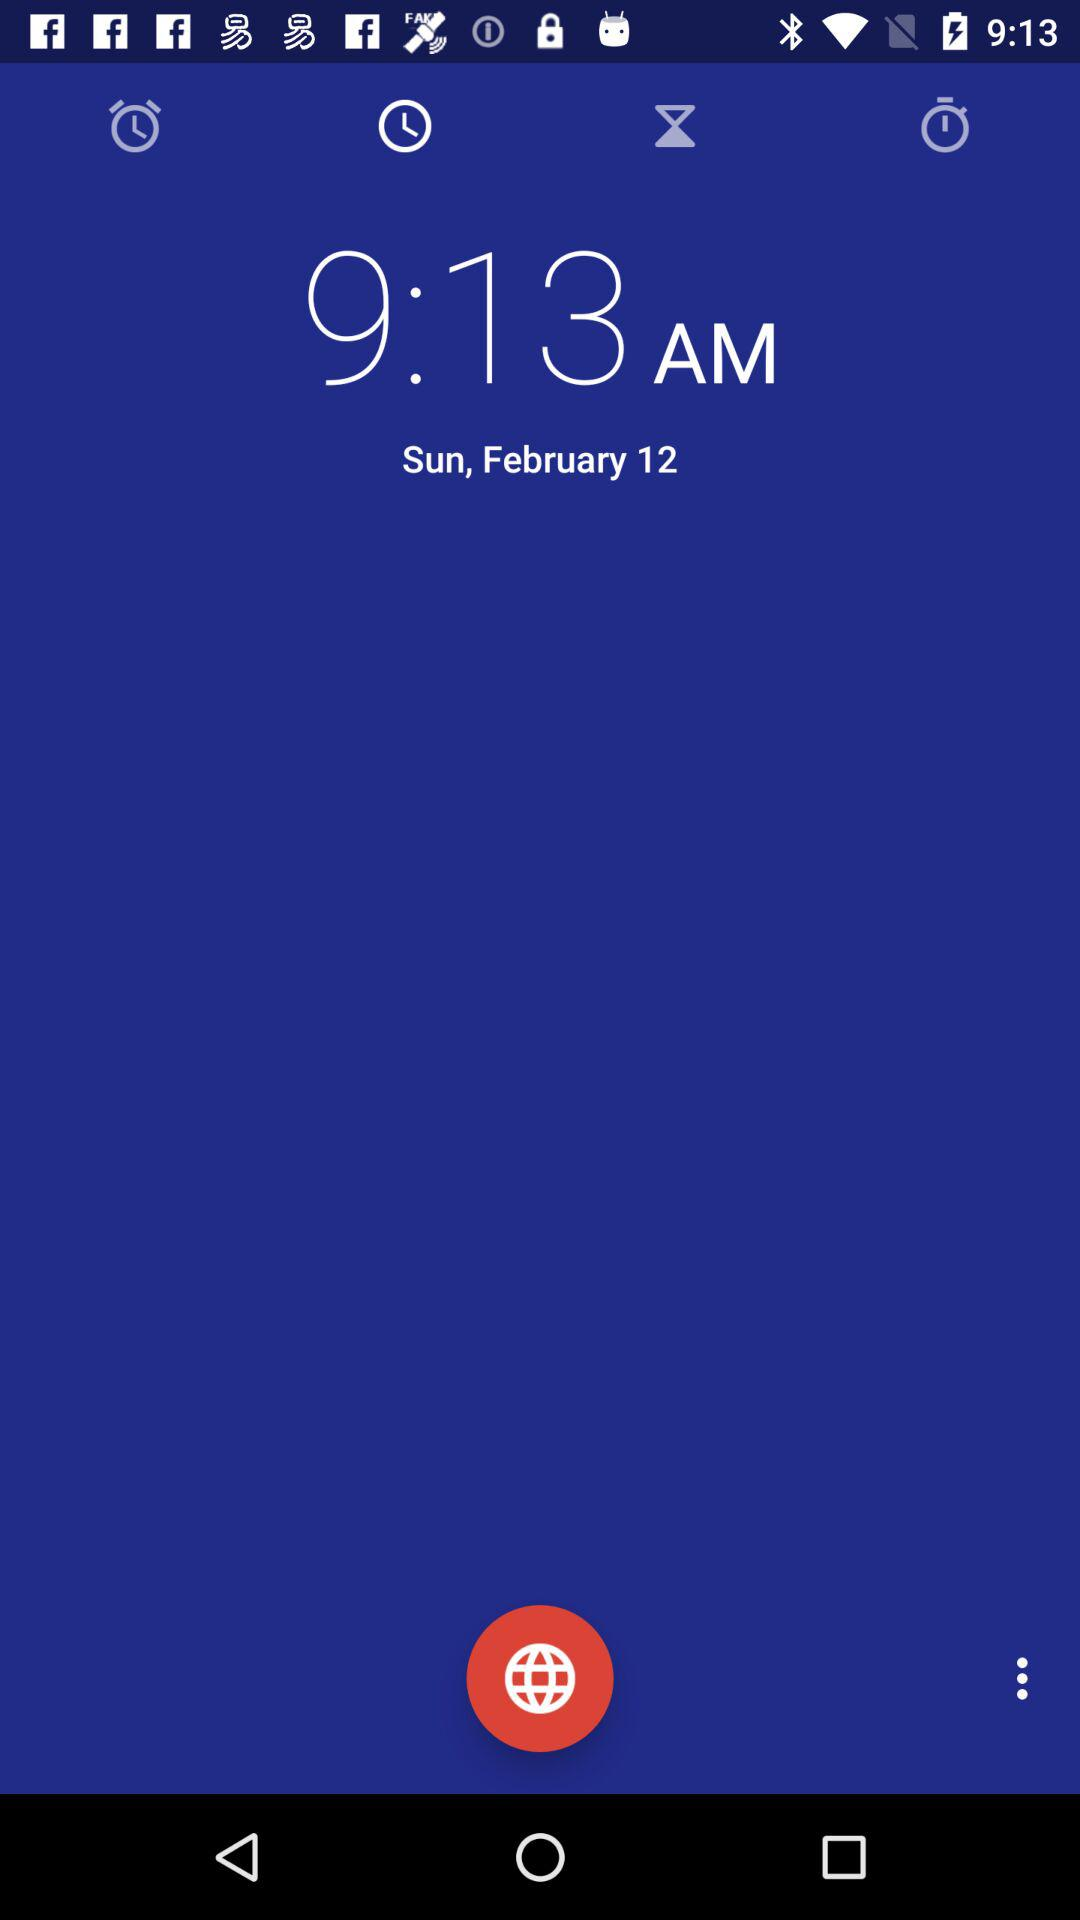What is the selected date? The date is Sunday, February 12. 